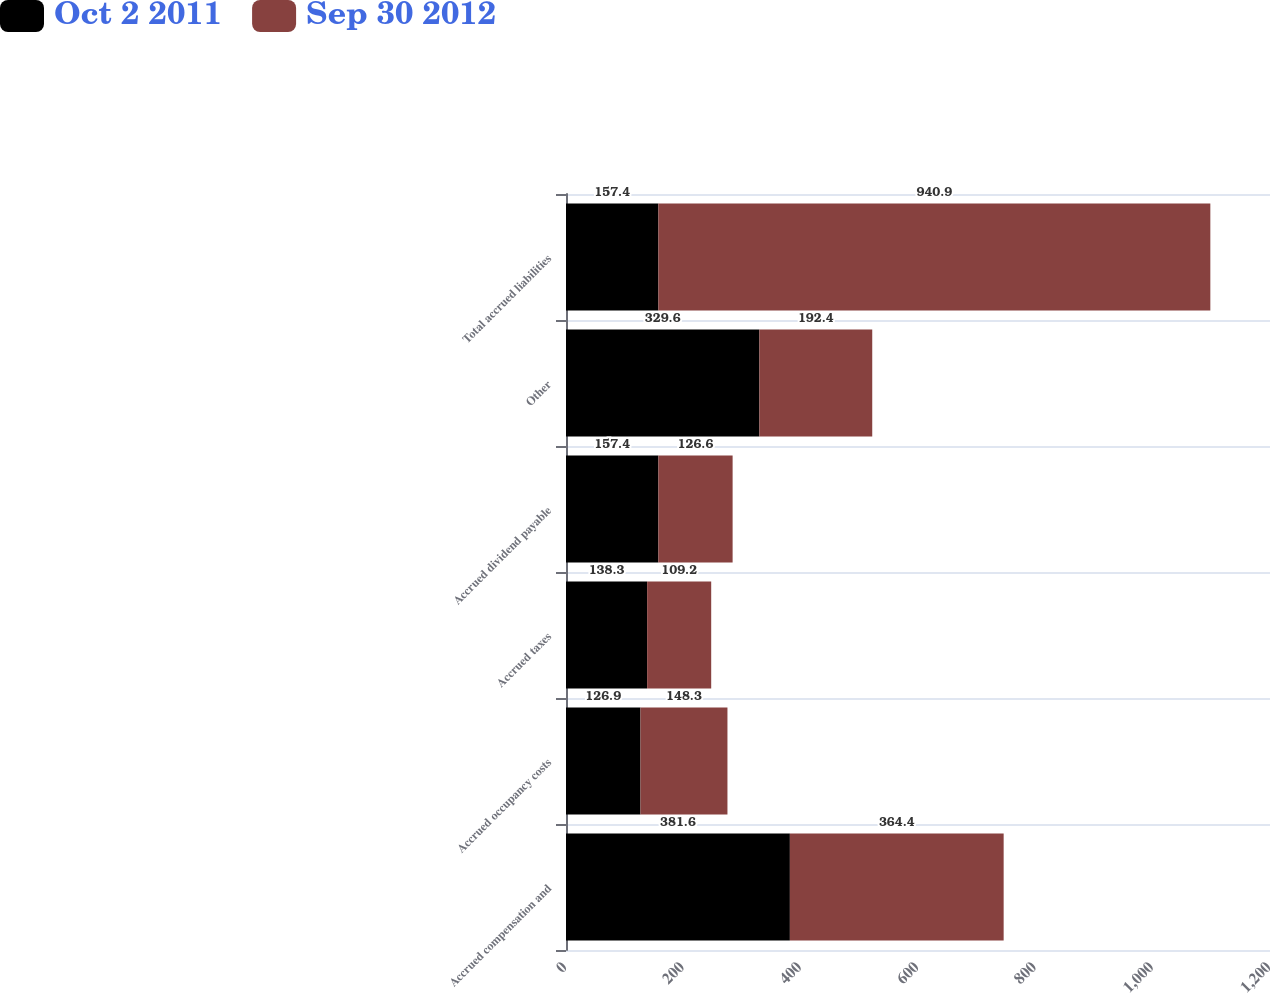Convert chart. <chart><loc_0><loc_0><loc_500><loc_500><stacked_bar_chart><ecel><fcel>Accrued compensation and<fcel>Accrued occupancy costs<fcel>Accrued taxes<fcel>Accrued dividend payable<fcel>Other<fcel>Total accrued liabilities<nl><fcel>Oct 2 2011<fcel>381.6<fcel>126.9<fcel>138.3<fcel>157.4<fcel>329.6<fcel>157.4<nl><fcel>Sep 30 2012<fcel>364.4<fcel>148.3<fcel>109.2<fcel>126.6<fcel>192.4<fcel>940.9<nl></chart> 